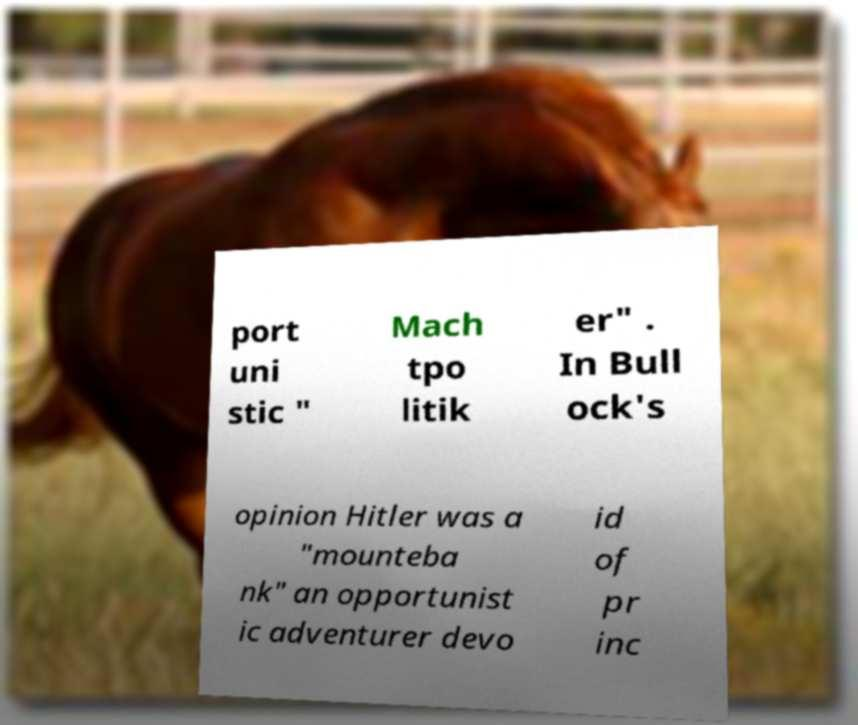Please identify and transcribe the text found in this image. port uni stic " Mach tpo litik er" . In Bull ock's opinion Hitler was a "mounteba nk" an opportunist ic adventurer devo id of pr inc 